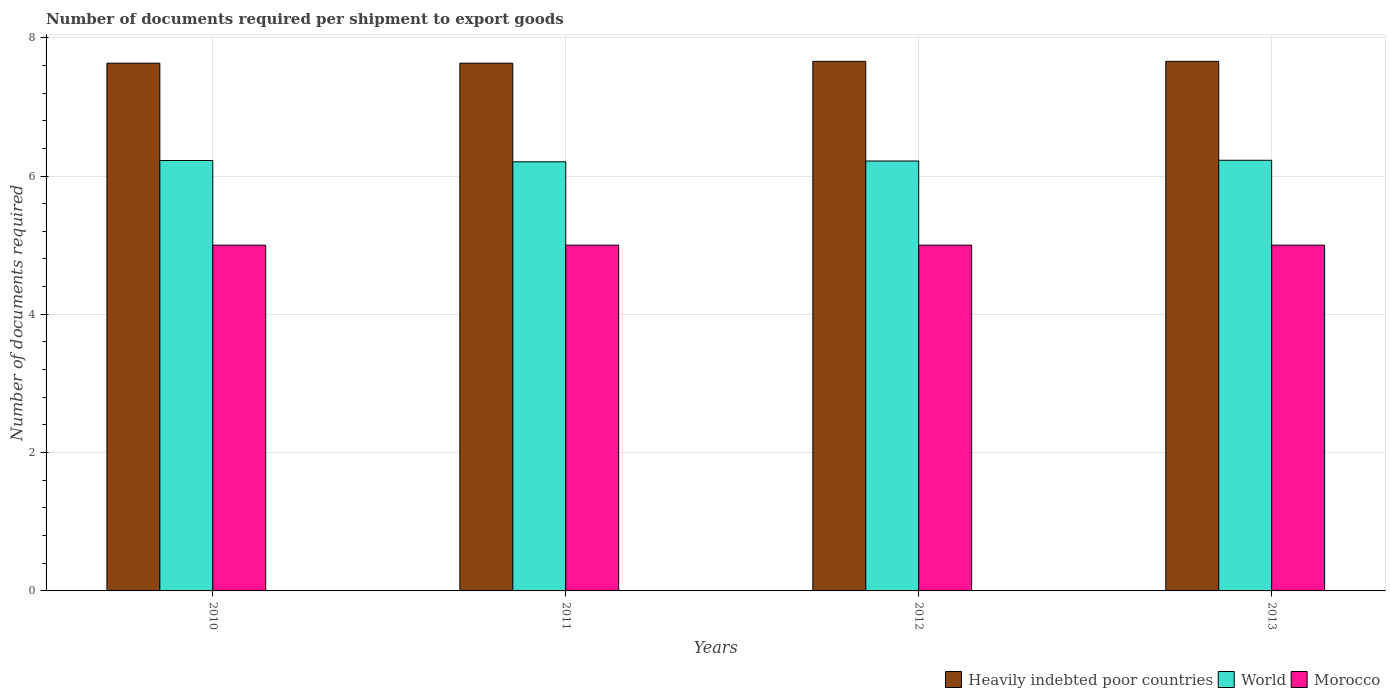How many different coloured bars are there?
Provide a short and direct response. 3. Are the number of bars on each tick of the X-axis equal?
Give a very brief answer. Yes. How many bars are there on the 2nd tick from the left?
Give a very brief answer. 3. How many bars are there on the 1st tick from the right?
Offer a very short reply. 3. What is the number of documents required per shipment to export goods in World in 2013?
Ensure brevity in your answer.  6.23. Across all years, what is the maximum number of documents required per shipment to export goods in Morocco?
Ensure brevity in your answer.  5. Across all years, what is the minimum number of documents required per shipment to export goods in Morocco?
Your response must be concise. 5. What is the total number of documents required per shipment to export goods in World in the graph?
Your response must be concise. 24.87. What is the difference between the number of documents required per shipment to export goods in Heavily indebted poor countries in 2012 and that in 2013?
Keep it short and to the point. 0. What is the difference between the number of documents required per shipment to export goods in Heavily indebted poor countries in 2012 and the number of documents required per shipment to export goods in World in 2013?
Your answer should be very brief. 1.43. What is the average number of documents required per shipment to export goods in Heavily indebted poor countries per year?
Ensure brevity in your answer.  7.64. In the year 2012, what is the difference between the number of documents required per shipment to export goods in World and number of documents required per shipment to export goods in Heavily indebted poor countries?
Ensure brevity in your answer.  -1.44. In how many years, is the number of documents required per shipment to export goods in Heavily indebted poor countries greater than 0.8?
Give a very brief answer. 4. What is the ratio of the number of documents required per shipment to export goods in World in 2010 to that in 2013?
Give a very brief answer. 1. Is the difference between the number of documents required per shipment to export goods in World in 2010 and 2012 greater than the difference between the number of documents required per shipment to export goods in Heavily indebted poor countries in 2010 and 2012?
Offer a very short reply. Yes. What is the difference between the highest and the second highest number of documents required per shipment to export goods in World?
Ensure brevity in your answer.  0. Is the sum of the number of documents required per shipment to export goods in Heavily indebted poor countries in 2012 and 2013 greater than the maximum number of documents required per shipment to export goods in Morocco across all years?
Offer a very short reply. Yes. What does the 2nd bar from the right in 2012 represents?
Provide a short and direct response. World. How many years are there in the graph?
Keep it short and to the point. 4. Does the graph contain grids?
Your response must be concise. Yes. How many legend labels are there?
Your answer should be compact. 3. What is the title of the graph?
Provide a succinct answer. Number of documents required per shipment to export goods. What is the label or title of the Y-axis?
Provide a short and direct response. Number of documents required. What is the Number of documents required in Heavily indebted poor countries in 2010?
Provide a succinct answer. 7.63. What is the Number of documents required of World in 2010?
Give a very brief answer. 6.22. What is the Number of documents required in Heavily indebted poor countries in 2011?
Give a very brief answer. 7.63. What is the Number of documents required in World in 2011?
Ensure brevity in your answer.  6.21. What is the Number of documents required of Morocco in 2011?
Your response must be concise. 5. What is the Number of documents required of Heavily indebted poor countries in 2012?
Offer a terse response. 7.66. What is the Number of documents required in World in 2012?
Your answer should be very brief. 6.22. What is the Number of documents required of Heavily indebted poor countries in 2013?
Your response must be concise. 7.66. What is the Number of documents required in World in 2013?
Your response must be concise. 6.23. Across all years, what is the maximum Number of documents required in Heavily indebted poor countries?
Keep it short and to the point. 7.66. Across all years, what is the maximum Number of documents required in World?
Offer a very short reply. 6.23. Across all years, what is the minimum Number of documents required of Heavily indebted poor countries?
Provide a succinct answer. 7.63. Across all years, what is the minimum Number of documents required in World?
Provide a short and direct response. 6.21. Across all years, what is the minimum Number of documents required of Morocco?
Your answer should be compact. 5. What is the total Number of documents required in Heavily indebted poor countries in the graph?
Offer a terse response. 30.58. What is the total Number of documents required in World in the graph?
Your answer should be very brief. 24.87. What is the difference between the Number of documents required of World in 2010 and that in 2011?
Give a very brief answer. 0.02. What is the difference between the Number of documents required of Morocco in 2010 and that in 2011?
Ensure brevity in your answer.  0. What is the difference between the Number of documents required in Heavily indebted poor countries in 2010 and that in 2012?
Your answer should be compact. -0.03. What is the difference between the Number of documents required in World in 2010 and that in 2012?
Your response must be concise. 0.01. What is the difference between the Number of documents required in Morocco in 2010 and that in 2012?
Your answer should be very brief. 0. What is the difference between the Number of documents required in Heavily indebted poor countries in 2010 and that in 2013?
Offer a very short reply. -0.03. What is the difference between the Number of documents required in World in 2010 and that in 2013?
Offer a very short reply. -0. What is the difference between the Number of documents required of Heavily indebted poor countries in 2011 and that in 2012?
Your response must be concise. -0.03. What is the difference between the Number of documents required in World in 2011 and that in 2012?
Your response must be concise. -0.01. What is the difference between the Number of documents required in Heavily indebted poor countries in 2011 and that in 2013?
Offer a very short reply. -0.03. What is the difference between the Number of documents required of World in 2011 and that in 2013?
Ensure brevity in your answer.  -0.02. What is the difference between the Number of documents required of Morocco in 2011 and that in 2013?
Give a very brief answer. 0. What is the difference between the Number of documents required of World in 2012 and that in 2013?
Ensure brevity in your answer.  -0.01. What is the difference between the Number of documents required of Heavily indebted poor countries in 2010 and the Number of documents required of World in 2011?
Your answer should be compact. 1.43. What is the difference between the Number of documents required in Heavily indebted poor countries in 2010 and the Number of documents required in Morocco in 2011?
Your answer should be compact. 2.63. What is the difference between the Number of documents required in World in 2010 and the Number of documents required in Morocco in 2011?
Offer a very short reply. 1.22. What is the difference between the Number of documents required in Heavily indebted poor countries in 2010 and the Number of documents required in World in 2012?
Provide a succinct answer. 1.41. What is the difference between the Number of documents required in Heavily indebted poor countries in 2010 and the Number of documents required in Morocco in 2012?
Your answer should be very brief. 2.63. What is the difference between the Number of documents required of World in 2010 and the Number of documents required of Morocco in 2012?
Keep it short and to the point. 1.22. What is the difference between the Number of documents required of Heavily indebted poor countries in 2010 and the Number of documents required of World in 2013?
Offer a terse response. 1.4. What is the difference between the Number of documents required in Heavily indebted poor countries in 2010 and the Number of documents required in Morocco in 2013?
Offer a terse response. 2.63. What is the difference between the Number of documents required of World in 2010 and the Number of documents required of Morocco in 2013?
Give a very brief answer. 1.22. What is the difference between the Number of documents required of Heavily indebted poor countries in 2011 and the Number of documents required of World in 2012?
Your answer should be compact. 1.41. What is the difference between the Number of documents required of Heavily indebted poor countries in 2011 and the Number of documents required of Morocco in 2012?
Make the answer very short. 2.63. What is the difference between the Number of documents required in World in 2011 and the Number of documents required in Morocco in 2012?
Provide a short and direct response. 1.21. What is the difference between the Number of documents required of Heavily indebted poor countries in 2011 and the Number of documents required of World in 2013?
Provide a succinct answer. 1.4. What is the difference between the Number of documents required of Heavily indebted poor countries in 2011 and the Number of documents required of Morocco in 2013?
Ensure brevity in your answer.  2.63. What is the difference between the Number of documents required of World in 2011 and the Number of documents required of Morocco in 2013?
Make the answer very short. 1.21. What is the difference between the Number of documents required in Heavily indebted poor countries in 2012 and the Number of documents required in World in 2013?
Provide a succinct answer. 1.43. What is the difference between the Number of documents required in Heavily indebted poor countries in 2012 and the Number of documents required in Morocco in 2013?
Your response must be concise. 2.66. What is the difference between the Number of documents required in World in 2012 and the Number of documents required in Morocco in 2013?
Ensure brevity in your answer.  1.22. What is the average Number of documents required in Heavily indebted poor countries per year?
Your answer should be very brief. 7.64. What is the average Number of documents required in World per year?
Give a very brief answer. 6.22. In the year 2010, what is the difference between the Number of documents required of Heavily indebted poor countries and Number of documents required of World?
Offer a terse response. 1.41. In the year 2010, what is the difference between the Number of documents required of Heavily indebted poor countries and Number of documents required of Morocco?
Provide a succinct answer. 2.63. In the year 2010, what is the difference between the Number of documents required of World and Number of documents required of Morocco?
Make the answer very short. 1.22. In the year 2011, what is the difference between the Number of documents required of Heavily indebted poor countries and Number of documents required of World?
Your response must be concise. 1.43. In the year 2011, what is the difference between the Number of documents required of Heavily indebted poor countries and Number of documents required of Morocco?
Ensure brevity in your answer.  2.63. In the year 2011, what is the difference between the Number of documents required of World and Number of documents required of Morocco?
Provide a short and direct response. 1.21. In the year 2012, what is the difference between the Number of documents required of Heavily indebted poor countries and Number of documents required of World?
Keep it short and to the point. 1.44. In the year 2012, what is the difference between the Number of documents required in Heavily indebted poor countries and Number of documents required in Morocco?
Offer a very short reply. 2.66. In the year 2012, what is the difference between the Number of documents required in World and Number of documents required in Morocco?
Give a very brief answer. 1.22. In the year 2013, what is the difference between the Number of documents required of Heavily indebted poor countries and Number of documents required of World?
Provide a short and direct response. 1.43. In the year 2013, what is the difference between the Number of documents required in Heavily indebted poor countries and Number of documents required in Morocco?
Provide a succinct answer. 2.66. In the year 2013, what is the difference between the Number of documents required of World and Number of documents required of Morocco?
Make the answer very short. 1.23. What is the ratio of the Number of documents required of Heavily indebted poor countries in 2010 to that in 2011?
Give a very brief answer. 1. What is the ratio of the Number of documents required of Heavily indebted poor countries in 2010 to that in 2012?
Your answer should be very brief. 1. What is the ratio of the Number of documents required of World in 2010 to that in 2012?
Provide a succinct answer. 1. What is the ratio of the Number of documents required of Morocco in 2010 to that in 2013?
Make the answer very short. 1. What is the ratio of the Number of documents required of World in 2011 to that in 2012?
Make the answer very short. 1. What is the ratio of the Number of documents required in World in 2011 to that in 2013?
Your answer should be very brief. 1. What is the ratio of the Number of documents required of Morocco in 2011 to that in 2013?
Your response must be concise. 1. What is the ratio of the Number of documents required in Morocco in 2012 to that in 2013?
Offer a terse response. 1. What is the difference between the highest and the second highest Number of documents required in World?
Keep it short and to the point. 0. What is the difference between the highest and the second highest Number of documents required of Morocco?
Your answer should be compact. 0. What is the difference between the highest and the lowest Number of documents required in Heavily indebted poor countries?
Provide a succinct answer. 0.03. What is the difference between the highest and the lowest Number of documents required of World?
Provide a short and direct response. 0.02. 